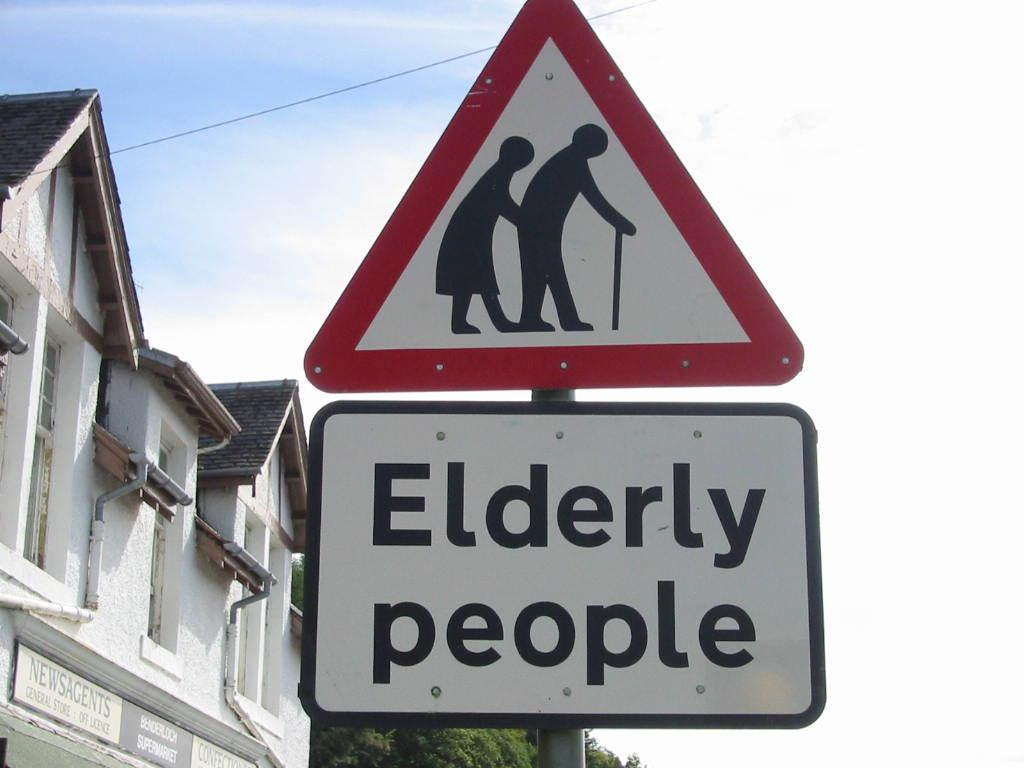<image>
Create a compact narrative representing the image presented. A triangular caution sign warning of Elderly people crossing the road. 